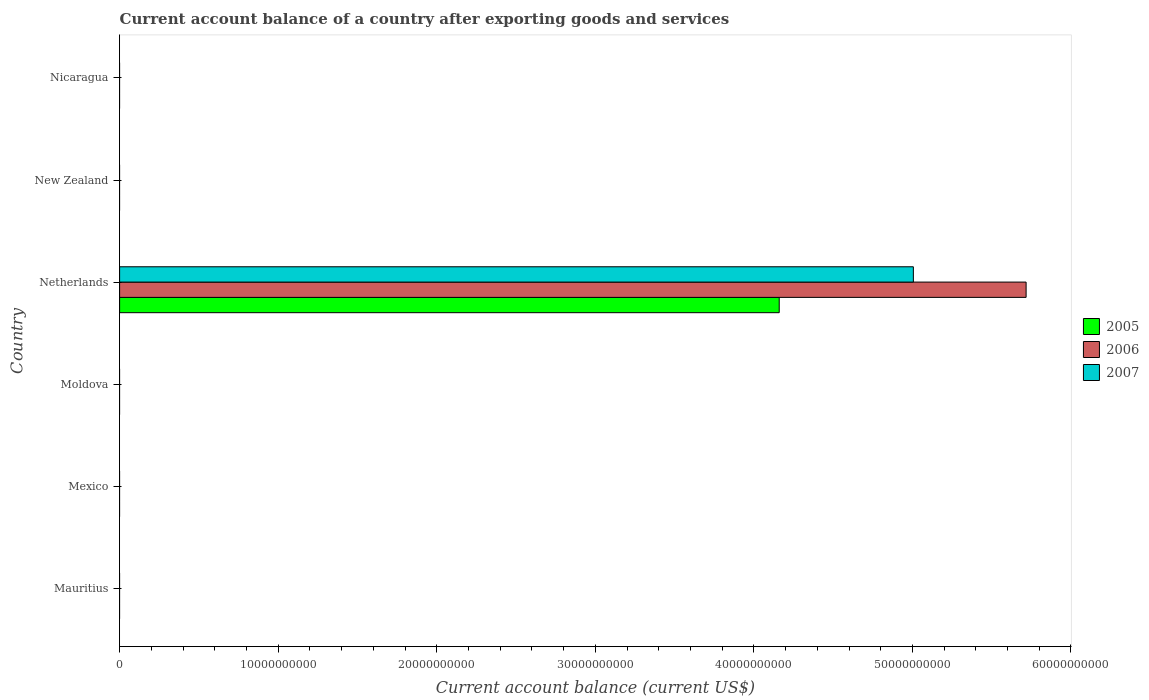Are the number of bars per tick equal to the number of legend labels?
Provide a succinct answer. No. Are the number of bars on each tick of the Y-axis equal?
Keep it short and to the point. No. What is the label of the 1st group of bars from the top?
Provide a succinct answer. Nicaragua. In how many cases, is the number of bars for a given country not equal to the number of legend labels?
Ensure brevity in your answer.  5. What is the account balance in 2007 in Mexico?
Give a very brief answer. 0. Across all countries, what is the maximum account balance in 2005?
Your response must be concise. 4.16e+1. Across all countries, what is the minimum account balance in 2006?
Offer a very short reply. 0. What is the total account balance in 2007 in the graph?
Provide a short and direct response. 5.01e+1. What is the difference between the account balance in 2007 in Moldova and the account balance in 2005 in Mauritius?
Offer a very short reply. 0. What is the average account balance in 2006 per country?
Make the answer very short. 9.53e+09. What is the difference between the account balance in 2005 and account balance in 2006 in Netherlands?
Your response must be concise. -1.56e+1. In how many countries, is the account balance in 2005 greater than 36000000000 US$?
Your answer should be very brief. 1. What is the difference between the highest and the lowest account balance in 2005?
Ensure brevity in your answer.  4.16e+1. What is the difference between two consecutive major ticks on the X-axis?
Offer a terse response. 1.00e+1. Are the values on the major ticks of X-axis written in scientific E-notation?
Your response must be concise. No. Does the graph contain any zero values?
Offer a terse response. Yes. Does the graph contain grids?
Ensure brevity in your answer.  No. How many legend labels are there?
Offer a very short reply. 3. How are the legend labels stacked?
Your response must be concise. Vertical. What is the title of the graph?
Keep it short and to the point. Current account balance of a country after exporting goods and services. What is the label or title of the X-axis?
Offer a very short reply. Current account balance (current US$). What is the label or title of the Y-axis?
Provide a succinct answer. Country. What is the Current account balance (current US$) of 2005 in Mauritius?
Make the answer very short. 0. What is the Current account balance (current US$) of 2006 in Mauritius?
Keep it short and to the point. 0. What is the Current account balance (current US$) in 2007 in Mauritius?
Offer a very short reply. 0. What is the Current account balance (current US$) in 2005 in Mexico?
Offer a terse response. 0. What is the Current account balance (current US$) in 2005 in Netherlands?
Offer a very short reply. 4.16e+1. What is the Current account balance (current US$) in 2006 in Netherlands?
Offer a terse response. 5.72e+1. What is the Current account balance (current US$) in 2007 in Netherlands?
Provide a short and direct response. 5.01e+1. What is the Current account balance (current US$) in 2005 in New Zealand?
Your answer should be compact. 0. What is the Current account balance (current US$) in 2006 in New Zealand?
Ensure brevity in your answer.  0. What is the Current account balance (current US$) of 2007 in Nicaragua?
Your response must be concise. 0. Across all countries, what is the maximum Current account balance (current US$) in 2005?
Offer a very short reply. 4.16e+1. Across all countries, what is the maximum Current account balance (current US$) of 2006?
Offer a terse response. 5.72e+1. Across all countries, what is the maximum Current account balance (current US$) in 2007?
Provide a short and direct response. 5.01e+1. What is the total Current account balance (current US$) of 2005 in the graph?
Give a very brief answer. 4.16e+1. What is the total Current account balance (current US$) in 2006 in the graph?
Your response must be concise. 5.72e+1. What is the total Current account balance (current US$) of 2007 in the graph?
Provide a succinct answer. 5.01e+1. What is the average Current account balance (current US$) in 2005 per country?
Your answer should be very brief. 6.93e+09. What is the average Current account balance (current US$) in 2006 per country?
Ensure brevity in your answer.  9.53e+09. What is the average Current account balance (current US$) of 2007 per country?
Keep it short and to the point. 8.34e+09. What is the difference between the Current account balance (current US$) in 2005 and Current account balance (current US$) in 2006 in Netherlands?
Provide a short and direct response. -1.56e+1. What is the difference between the Current account balance (current US$) of 2005 and Current account balance (current US$) of 2007 in Netherlands?
Provide a short and direct response. -8.46e+09. What is the difference between the Current account balance (current US$) in 2006 and Current account balance (current US$) in 2007 in Netherlands?
Your answer should be compact. 7.11e+09. What is the difference between the highest and the lowest Current account balance (current US$) of 2005?
Your response must be concise. 4.16e+1. What is the difference between the highest and the lowest Current account balance (current US$) of 2006?
Your response must be concise. 5.72e+1. What is the difference between the highest and the lowest Current account balance (current US$) in 2007?
Make the answer very short. 5.01e+1. 